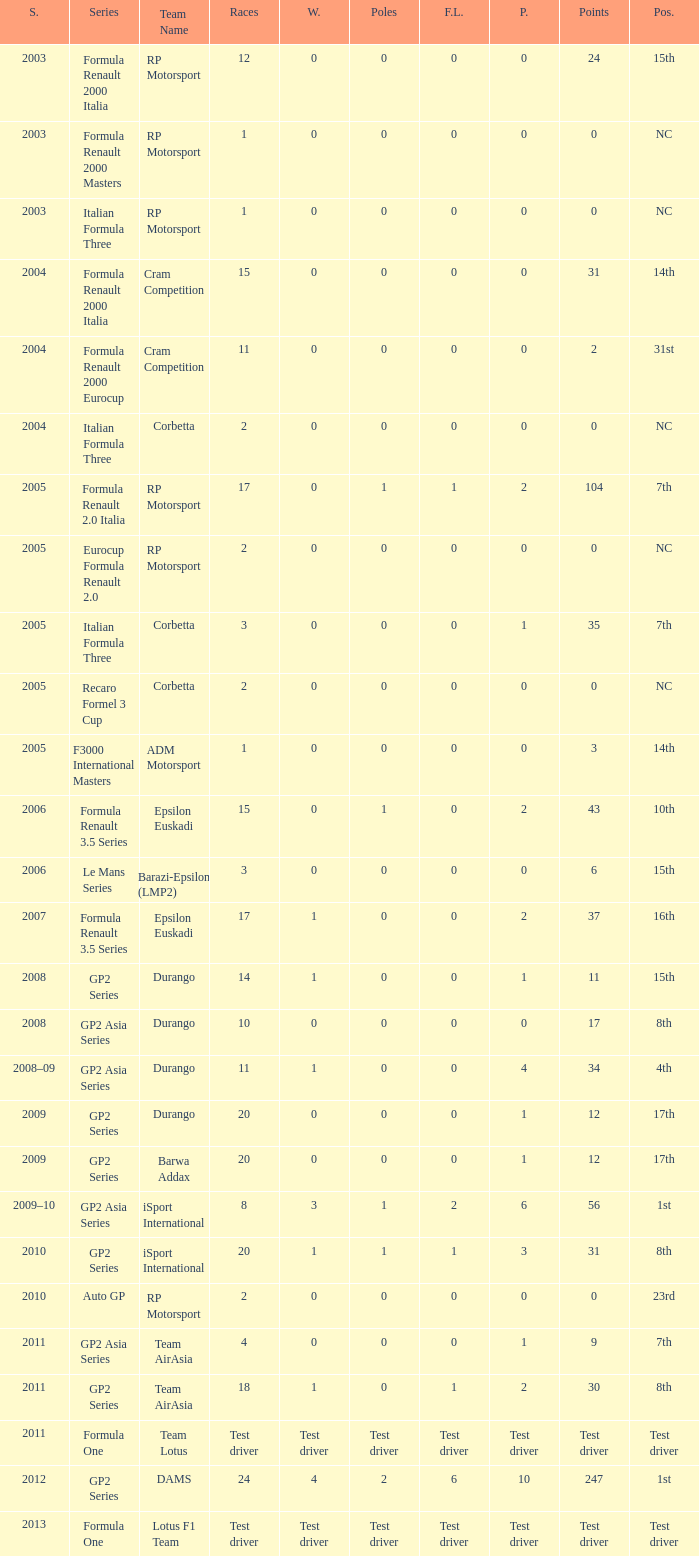What is the number of podiums with 0 wins, 0 F.L. and 35 points? 1.0. Could you parse the entire table? {'header': ['S.', 'Series', 'Team Name', 'Races', 'W.', 'Poles', 'F.L.', 'P.', 'Points', 'Pos.'], 'rows': [['2003', 'Formula Renault 2000 Italia', 'RP Motorsport', '12', '0', '0', '0', '0', '24', '15th'], ['2003', 'Formula Renault 2000 Masters', 'RP Motorsport', '1', '0', '0', '0', '0', '0', 'NC'], ['2003', 'Italian Formula Three', 'RP Motorsport', '1', '0', '0', '0', '0', '0', 'NC'], ['2004', 'Formula Renault 2000 Italia', 'Cram Competition', '15', '0', '0', '0', '0', '31', '14th'], ['2004', 'Formula Renault 2000 Eurocup', 'Cram Competition', '11', '0', '0', '0', '0', '2', '31st'], ['2004', 'Italian Formula Three', 'Corbetta', '2', '0', '0', '0', '0', '0', 'NC'], ['2005', 'Formula Renault 2.0 Italia', 'RP Motorsport', '17', '0', '1', '1', '2', '104', '7th'], ['2005', 'Eurocup Formula Renault 2.0', 'RP Motorsport', '2', '0', '0', '0', '0', '0', 'NC'], ['2005', 'Italian Formula Three', 'Corbetta', '3', '0', '0', '0', '1', '35', '7th'], ['2005', 'Recaro Formel 3 Cup', 'Corbetta', '2', '0', '0', '0', '0', '0', 'NC'], ['2005', 'F3000 International Masters', 'ADM Motorsport', '1', '0', '0', '0', '0', '3', '14th'], ['2006', 'Formula Renault 3.5 Series', 'Epsilon Euskadi', '15', '0', '1', '0', '2', '43', '10th'], ['2006', 'Le Mans Series', 'Barazi-Epsilon (LMP2)', '3', '0', '0', '0', '0', '6', '15th'], ['2007', 'Formula Renault 3.5 Series', 'Epsilon Euskadi', '17', '1', '0', '0', '2', '37', '16th'], ['2008', 'GP2 Series', 'Durango', '14', '1', '0', '0', '1', '11', '15th'], ['2008', 'GP2 Asia Series', 'Durango', '10', '0', '0', '0', '0', '17', '8th'], ['2008–09', 'GP2 Asia Series', 'Durango', '11', '1', '0', '0', '4', '34', '4th'], ['2009', 'GP2 Series', 'Durango', '20', '0', '0', '0', '1', '12', '17th'], ['2009', 'GP2 Series', 'Barwa Addax', '20', '0', '0', '0', '1', '12', '17th'], ['2009–10', 'GP2 Asia Series', 'iSport International', '8', '3', '1', '2', '6', '56', '1st'], ['2010', 'GP2 Series', 'iSport International', '20', '1', '1', '1', '3', '31', '8th'], ['2010', 'Auto GP', 'RP Motorsport', '2', '0', '0', '0', '0', '0', '23rd'], ['2011', 'GP2 Asia Series', 'Team AirAsia', '4', '0', '0', '0', '1', '9', '7th'], ['2011', 'GP2 Series', 'Team AirAsia', '18', '1', '0', '1', '2', '30', '8th'], ['2011', 'Formula One', 'Team Lotus', 'Test driver', 'Test driver', 'Test driver', 'Test driver', 'Test driver', 'Test driver', 'Test driver'], ['2012', 'GP2 Series', 'DAMS', '24', '4', '2', '6', '10', '247', '1st'], ['2013', 'Formula One', 'Lotus F1 Team', 'Test driver', 'Test driver', 'Test driver', 'Test driver', 'Test driver', 'Test driver', 'Test driver']]} 